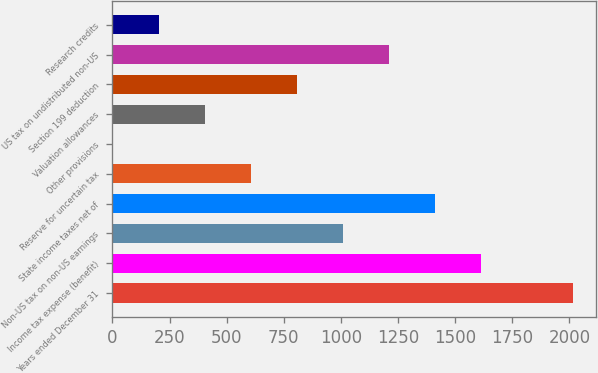<chart> <loc_0><loc_0><loc_500><loc_500><bar_chart><fcel>Years ended December 31<fcel>Income tax expense (benefit)<fcel>Non-US tax on non-US earnings<fcel>State income taxes net of<fcel>Reserve for uncertain tax<fcel>Other provisions<fcel>Valuation allowances<fcel>Section 199 deduction<fcel>US tax on undistributed non-US<fcel>Research credits<nl><fcel>2016<fcel>1613.2<fcel>1009<fcel>1411.8<fcel>606.2<fcel>2<fcel>404.8<fcel>807.6<fcel>1210.4<fcel>203.4<nl></chart> 